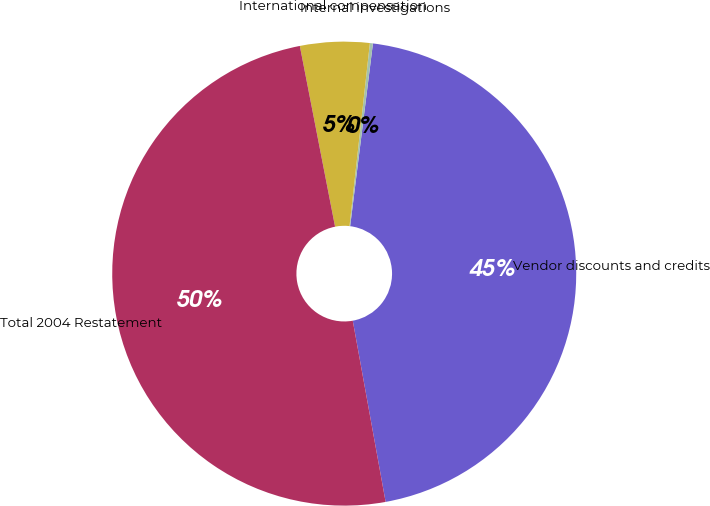Convert chart. <chart><loc_0><loc_0><loc_500><loc_500><pie_chart><fcel>Vendor discounts and credits<fcel>Internal investigations<fcel>International compensation<fcel>Total 2004 Restatement<nl><fcel>45.17%<fcel>0.21%<fcel>4.83%<fcel>49.79%<nl></chart> 